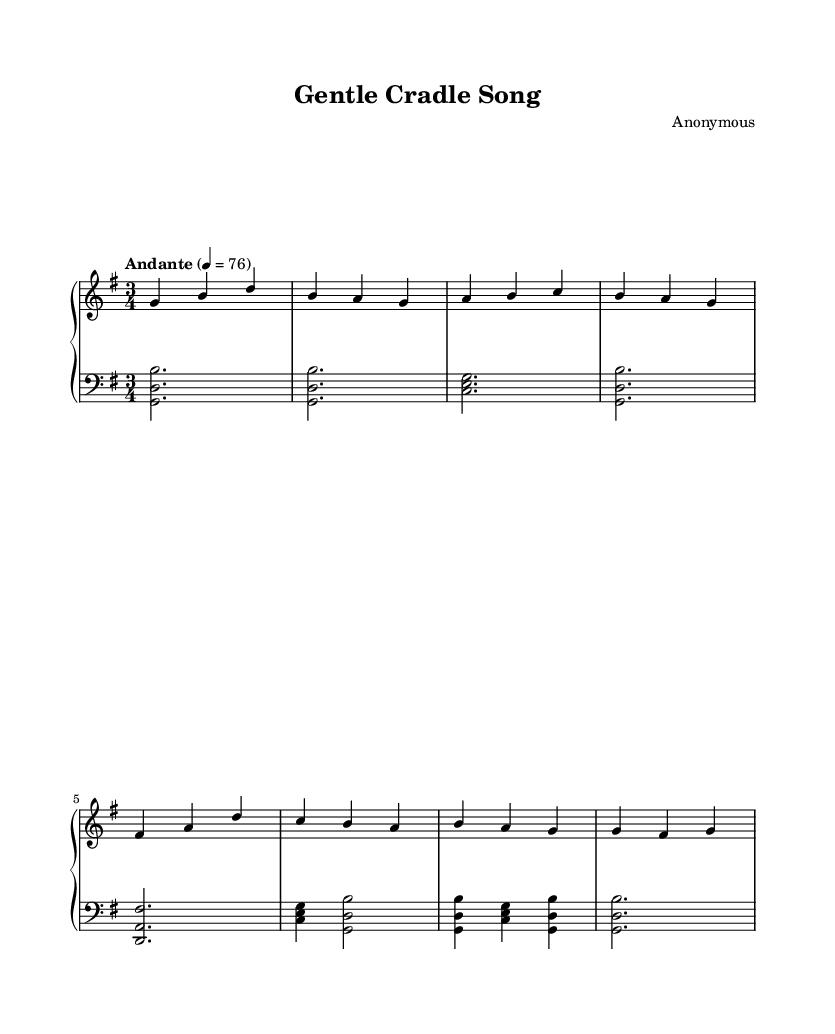What is the key signature of this music? The key signature is G major, indicated by one sharp (F#).
Answer: G major What is the time signature of this piece? The time signature is 3/4, which means there are three beats in each measure and a quarter note gets one beat.
Answer: 3/4 What is the tempo marking of this lullaby? The tempo marking is Andante, which usually suggests a moderately slow pace.
Answer: Andante How many measures are in the melody? Counting the rhythmic groupings, there are eight measures in the melody line provided.
Answer: Eight What is the composer of this piece? The composer is listed as Anonymous, indicating that the specific composer is unknown.
Answer: Anonymous What are the instrumental parts used in this score? The score features two piano staves: upper for melody and lower for harmony.
Answer: Piano Is this piece typically considered a lullaby within its musical context? Yes, it is designated as a "Gentle Cradle Song," which characteristically serves as a lullaby.
Answer: Yes 